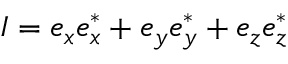<formula> <loc_0><loc_0><loc_500><loc_500>I = e _ { x } e _ { x } ^ { * } + e _ { y } e _ { y } ^ { * } + e _ { z } e _ { z } ^ { * }</formula> 